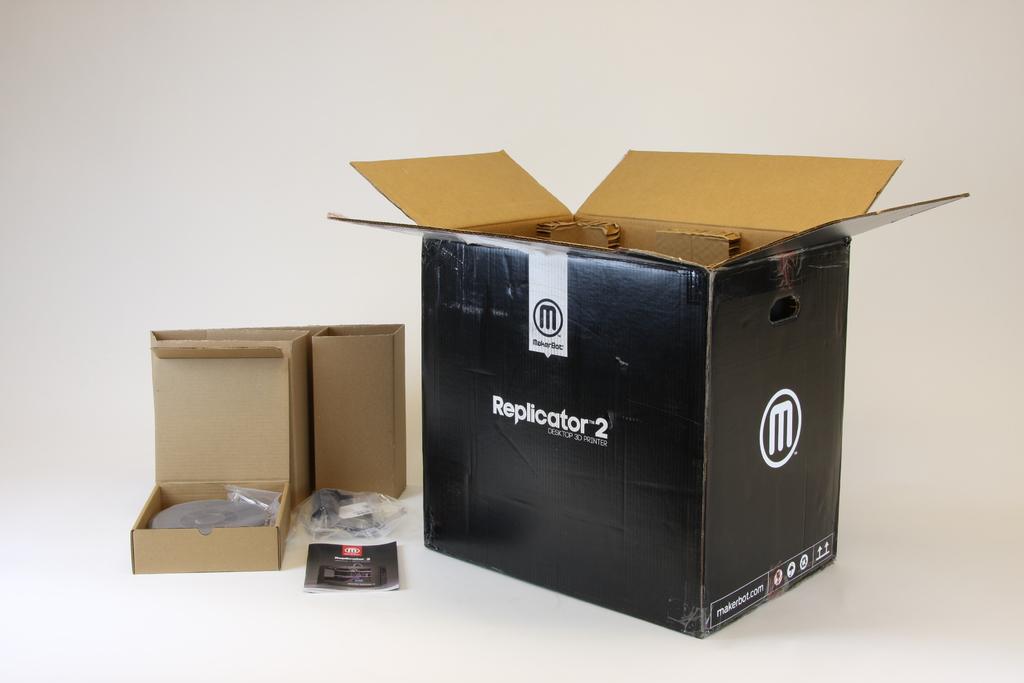What letter is in the white circle on the box?
Your response must be concise. M. 